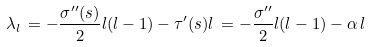Convert formula to latex. <formula><loc_0><loc_0><loc_500><loc_500>\lambda _ { l } \, = - \frac { \sigma ^ { \prime \prime } ( s ) } { 2 } l ( l - 1 ) - \tau ^ { \prime } ( s ) l \, = - \frac { \sigma ^ { \prime \prime } } { 2 } l ( l - 1 ) - \alpha \, l</formula> 